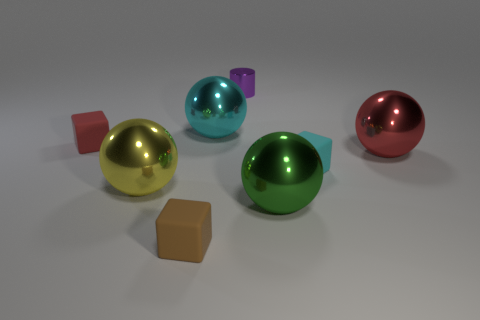Subtract 1 spheres. How many spheres are left? 3 Add 1 green shiny things. How many objects exist? 9 Subtract all cylinders. How many objects are left? 7 Subtract 1 purple cylinders. How many objects are left? 7 Subtract all cyan spheres. Subtract all yellow spheres. How many objects are left? 6 Add 1 big red metallic things. How many big red metallic things are left? 2 Add 8 tiny blue cylinders. How many tiny blue cylinders exist? 8 